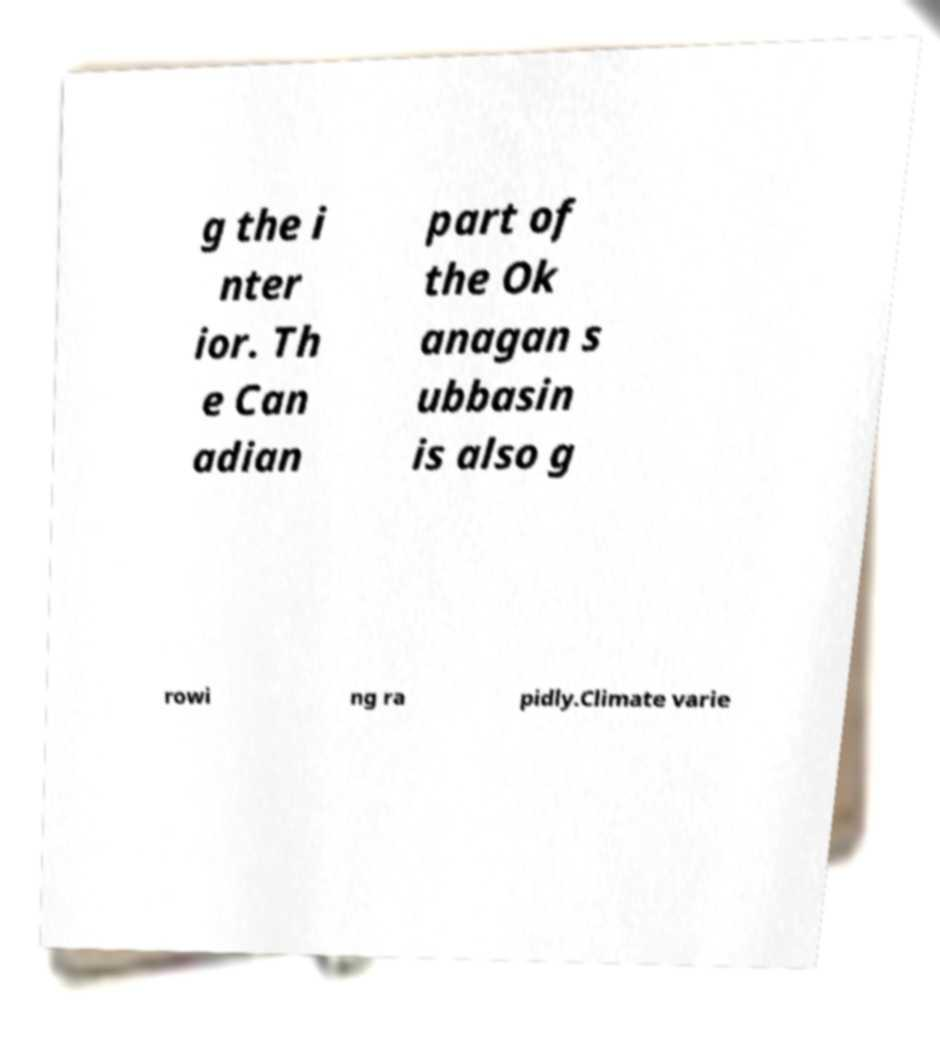What messages or text are displayed in this image? I need them in a readable, typed format. g the i nter ior. Th e Can adian part of the Ok anagan s ubbasin is also g rowi ng ra pidly.Climate varie 